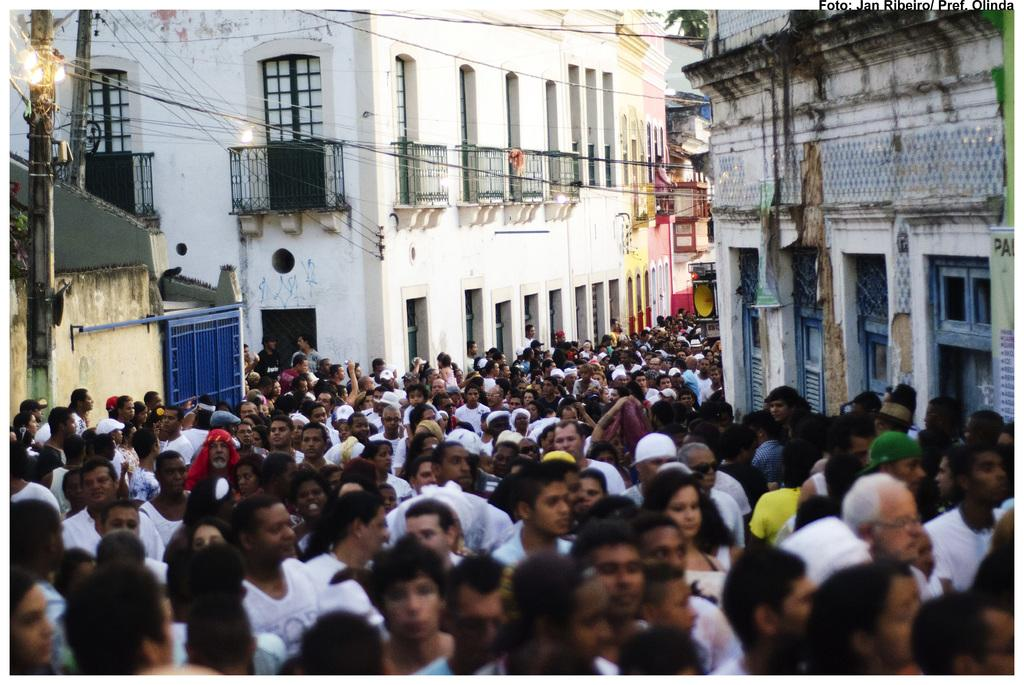What can be seen at the bottom of the image? There is a crowd at the bottom of the image. What is visible in the background of the image? Buildings, wires, poles, a light, a tree, and a gate are visible in the background of the image. What type of structures are present in the background? The background features buildings and a gate. What other objects can be seen in the background? Wires, poles, and a tree are also visible in the background. Where is the book located in the image? There is no book present in the image. What type of heart can be seen beating in the image? There is no heart visible in the image. 